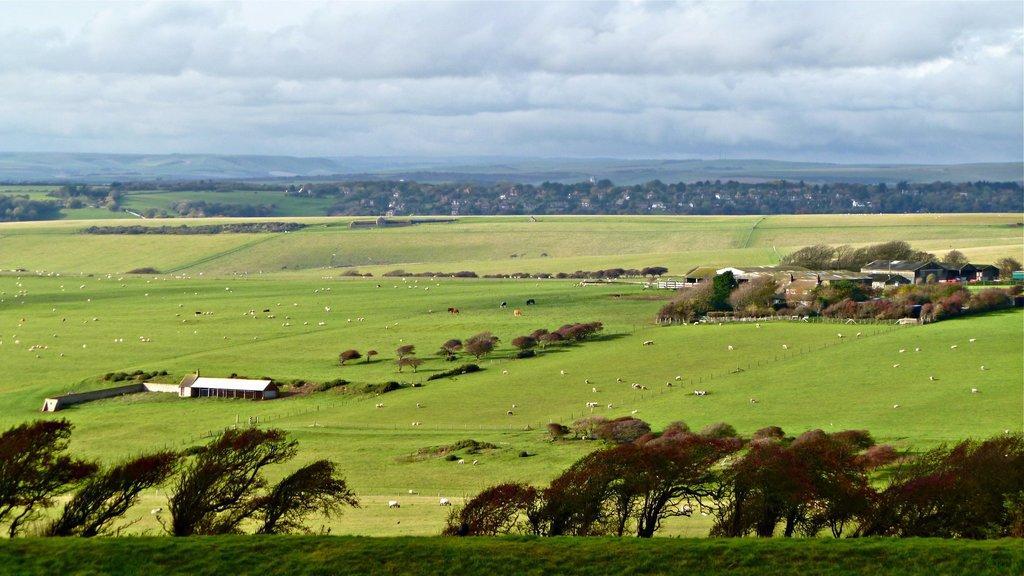In one or two sentences, can you explain what this image depicts? These are the trees with branches and leaves. These are the houses. I can see a flock of sheep and herd of cattle. In the background, these look like hills. I can see the clouds in the sky. 